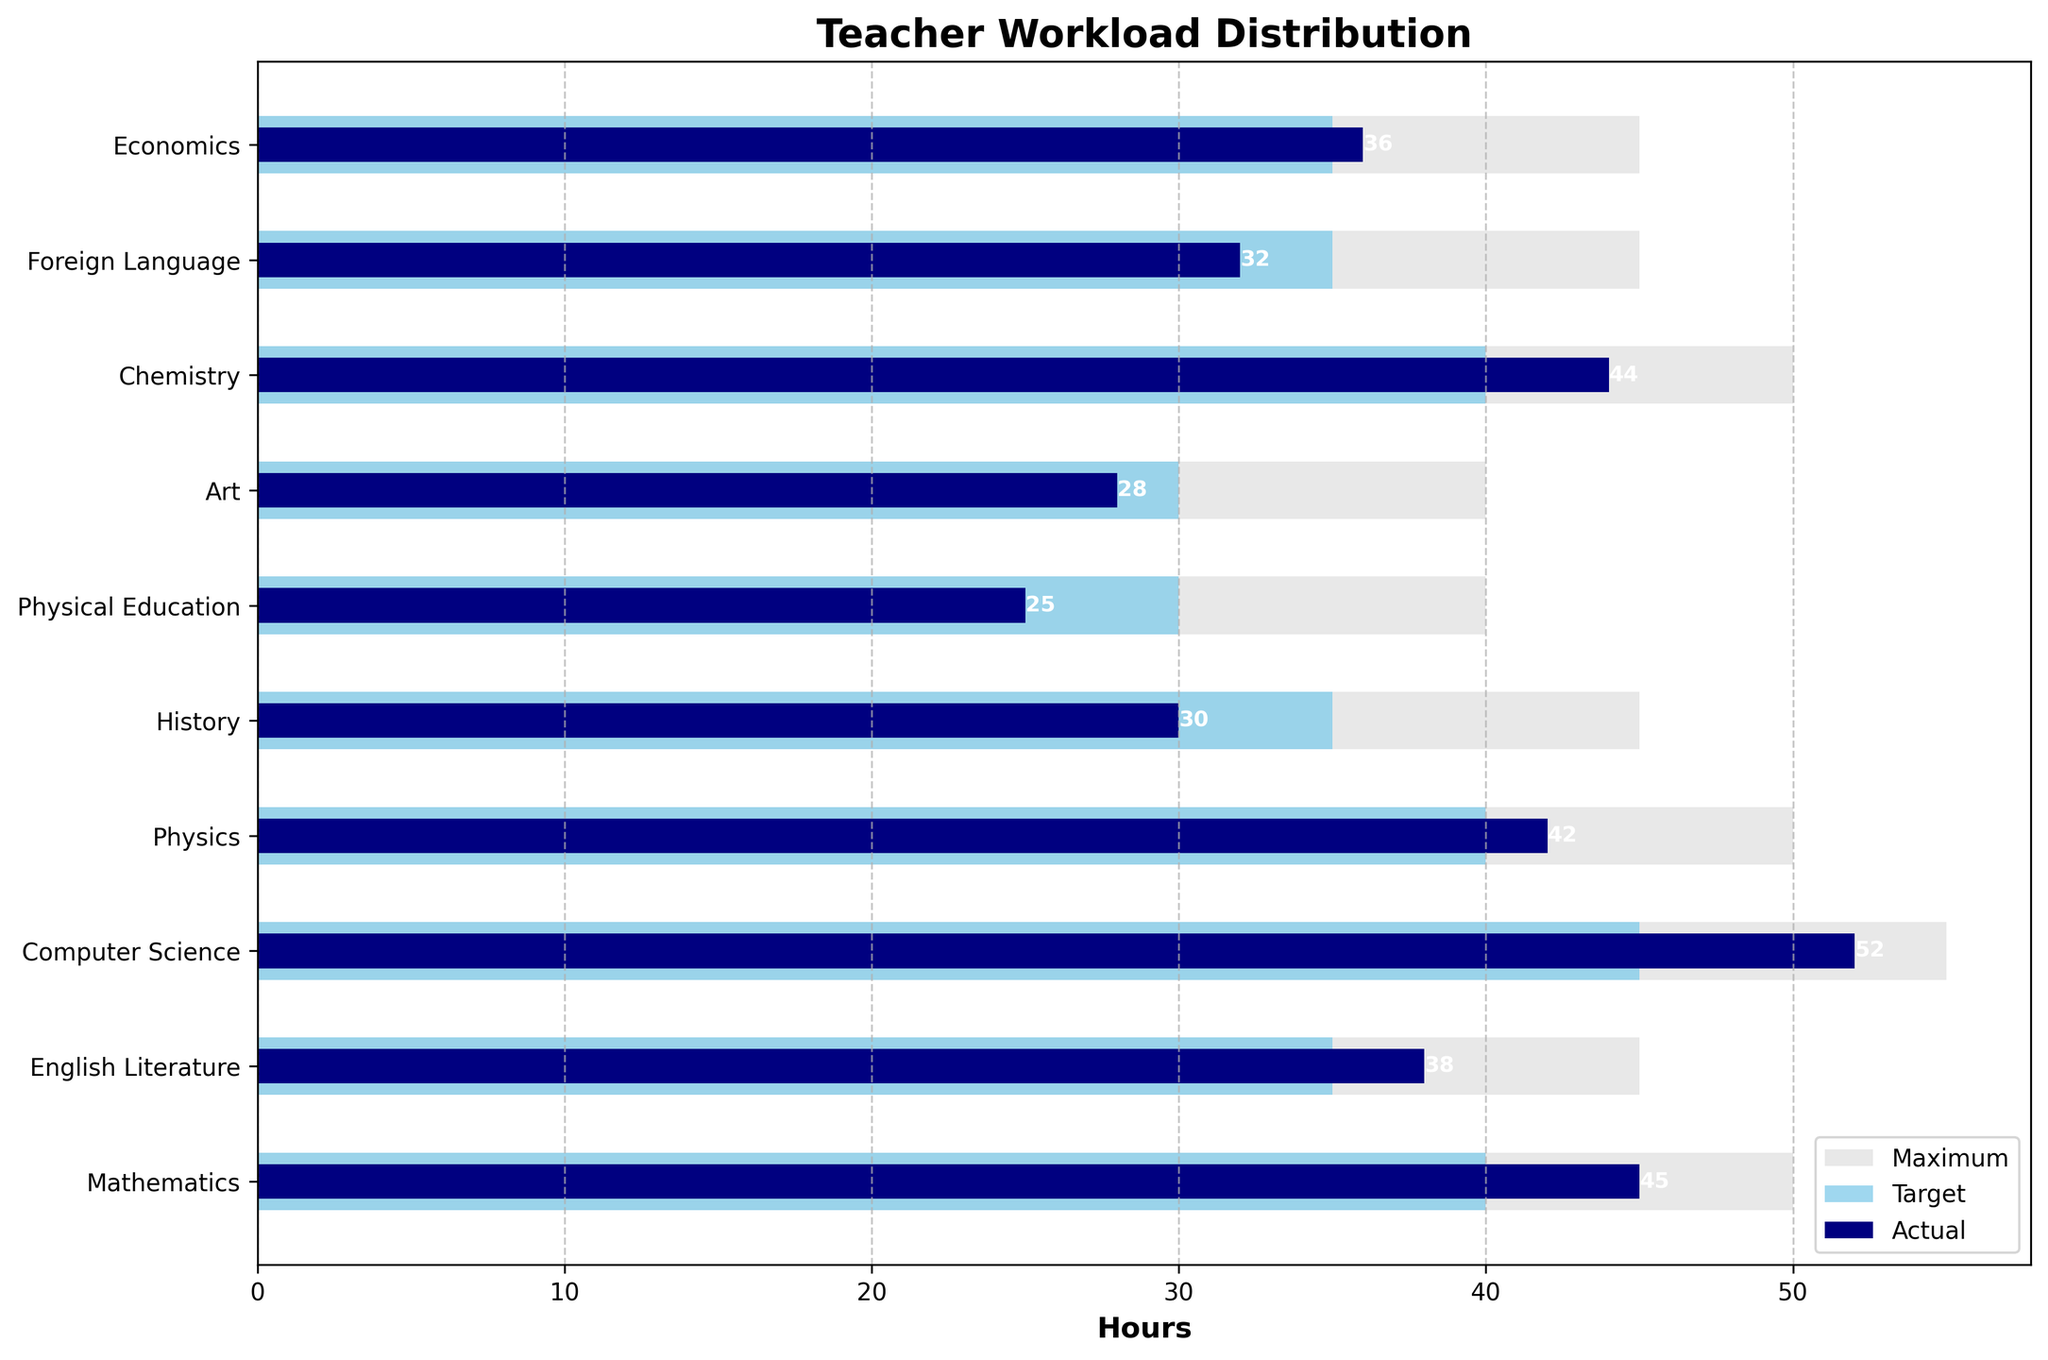What's the title of the figure? The title of the figure is prominently displayed at the top and is usually in a larger, bold font.
Answer: Teacher Workload Distribution How many subjects are presented in the chart? The y-axis lists each subject, which are the distinct categories in the chart. By counting the labels, we can determine the number of subjects.
Answer: 10 What is the actual workload for Computer Science? The bar representing Actual Hours is depicted in a darker color (navy). Checking the length and label for Computer Science will give us the actual workload in hours.
Answer: 52 Which subject has the highest target hours? The target hours are shown in the lighter blue bars. By comparing the lengths of these bars, we can find the subject with the maximum target hours.
Answer: Computer Science Is the actual workload in Mathematics above or below the target workload? Compare the actual workload bar (navy) with the target workload bar (skyblue) for Mathematics; observe which is longer/shorter.
Answer: Above What is the difference between the actual and target hours for Physical Education? Subtract the target hours (skyblue bar) from the actual hours (navy bar) for Physical Education.
Answer: -5 Which subject has the greatest gap between actual and maximum hours? The greatest gap can be found by observing the difference between the actual (navy) and maximum (lightgrey) bar lengths for each subject.
Answer: Computer Science What subject has the smallest target hours? Evaluate the lengths of the skyblue bars representing target hours, and find the smallest one.
Answer: Art and Physical Education (tie) How does the actual workload in History compare to its target and maximum hours? For History, compare the lengths of the navy bar (actual), skyblue bar (target), and lightgrey bar (maximum) to determine the relationship between them.
Answer: Actual < Target < Maximum In how many subjects is the actual workload above the target workload? Count the number of instances where the navy bar (actual) exceeds the skyblue bar (target) across all subjects.
Answer: 5 